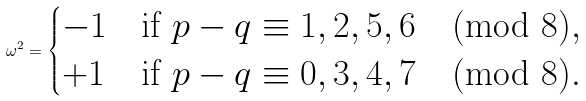<formula> <loc_0><loc_0><loc_500><loc_500>\omega ^ { 2 } = \begin{cases} - 1 & \text {if $p-q\equiv 1,2,5,6\pmod{8}$} , \\ + 1 & \text {if $p-q\equiv 0,3,4,7\pmod{8}$} . \end{cases}</formula> 